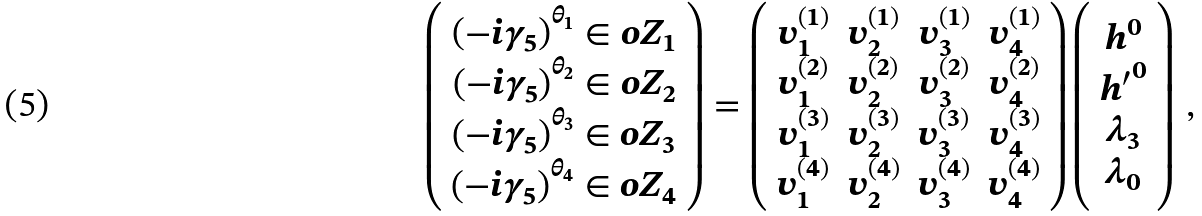<formula> <loc_0><loc_0><loc_500><loc_500>\left ( \begin{array} { c } \left ( - i \gamma _ { 5 } \right ) ^ { \theta _ { 1 } } \in o { Z } _ { 1 } \\ \left ( - i \gamma _ { 5 } \right ) ^ { \theta _ { 2 } } \in o { Z } _ { 2 } \\ \left ( - i \gamma _ { 5 } \right ) ^ { \theta _ { 3 } } \in o { Z } _ { 3 } \\ \left ( - i \gamma _ { 5 } \right ) ^ { \theta _ { 4 } } \in o { Z } _ { 4 } \end{array} \right ) = \left ( \begin{array} { c c c c } v _ { 1 } ^ { ( 1 ) } & v _ { 2 } ^ { ( 1 ) } & v _ { 3 } ^ { ( 1 ) } & v _ { 4 } ^ { ( 1 ) } \\ v _ { 1 } ^ { ( 2 ) } & v _ { 2 } ^ { ( 2 ) } & v _ { 3 } ^ { ( 2 ) } & v _ { 4 } ^ { ( 2 ) } \\ v _ { 1 } ^ { ( 3 ) } & v _ { 2 } ^ { ( 3 ) } & v _ { 3 } ^ { ( 3 ) } & v _ { 4 } ^ { ( 3 ) } \\ v _ { 1 } ^ { ( 4 ) } & v _ { 2 } ^ { ( 4 ) } & v _ { 3 } ^ { ( 4 ) } & v _ { 4 } ^ { ( 4 ) } \end{array} \right ) \left ( \begin{array} { c } h ^ { 0 } \\ { h ^ { \prime } } ^ { 0 } \\ \lambda _ { 3 } \\ \lambda _ { 0 } \end{array} \right ) \, ,</formula> 